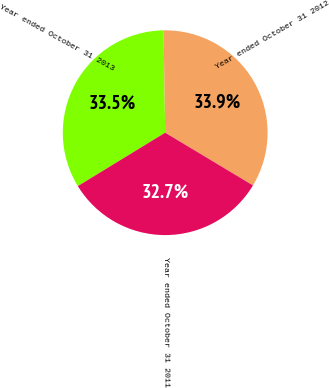<chart> <loc_0><loc_0><loc_500><loc_500><pie_chart><fcel>Year ended October 31 2013<fcel>Year ended October 31 2012<fcel>Year ended October 31 2011<nl><fcel>33.48%<fcel>33.86%<fcel>32.66%<nl></chart> 